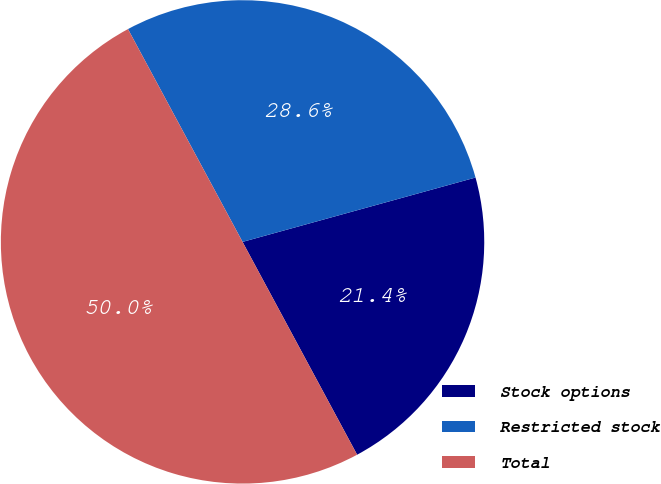Convert chart to OTSL. <chart><loc_0><loc_0><loc_500><loc_500><pie_chart><fcel>Stock options<fcel>Restricted stock<fcel>Total<nl><fcel>21.43%<fcel>28.57%<fcel>50.0%<nl></chart> 